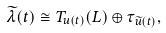<formula> <loc_0><loc_0><loc_500><loc_500>\widetilde { \lambda } ( t ) \cong T _ { u ( t ) } ( L ) \oplus \tau _ { \widetilde { u } ( t ) } ,</formula> 